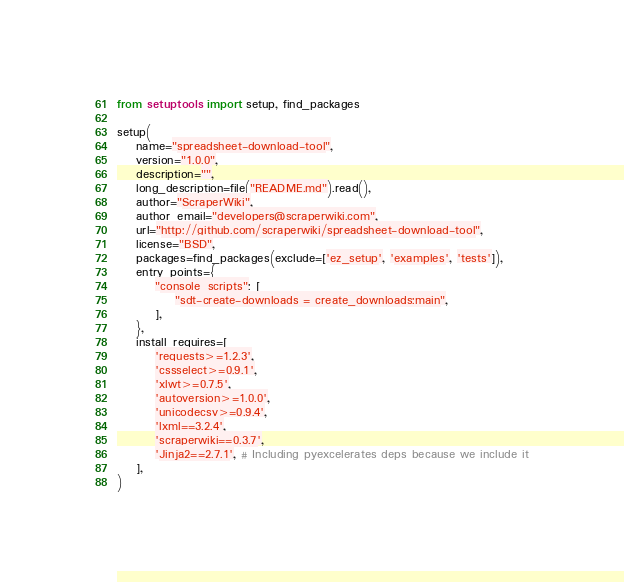<code> <loc_0><loc_0><loc_500><loc_500><_Python_>from setuptools import setup, find_packages

setup(
    name="spreadsheet-download-tool",
    version="1.0.0",
    description="",
    long_description=file("README.md").read(),
    author="ScraperWiki",
    author_email="developers@scraperwiki.com",
    url="http://github.com/scraperwiki/spreadsheet-download-tool",
    license="BSD",
    packages=find_packages(exclude=['ez_setup', 'examples', 'tests']),
    entry_points={
        "console_scripts": [
            "sdt-create-downloads = create_downloads:main",
        ],
    },
    install_requires=[
        'requests>=1.2.3',
        'cssselect>=0.9.1',
        'xlwt>=0.7.5',
        'autoversion>=1.0.0',
        'unicodecsv>=0.9.4',
        'lxml==3.2.4',
        'scraperwiki==0.3.7',
        'Jinja2==2.7.1', # Including pyexcelerates deps because we include it
    ],
)
</code> 